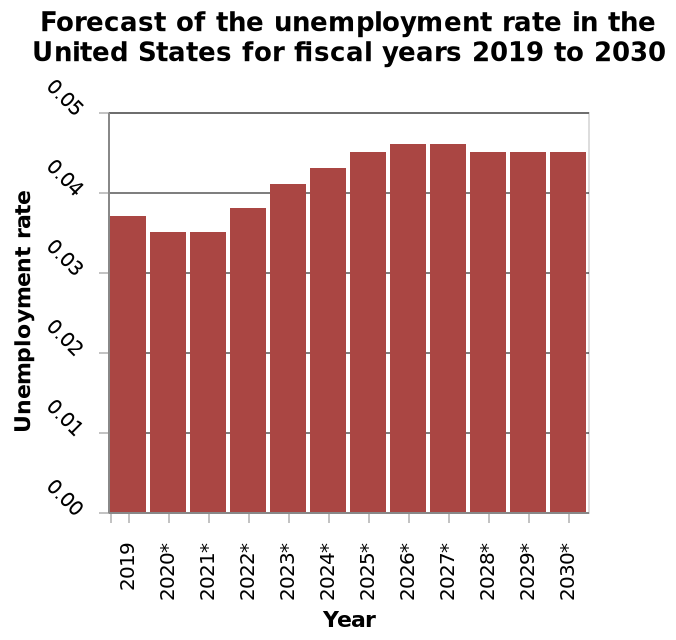<image>
Describe the following image in detail Here a is a bar graph called Forecast of the unemployment rate in the United States for fiscal years 2019 to 2030. The y-axis plots Unemployment rate with linear scale from 0.00 to 0.05 while the x-axis measures Year as categorical scale from 2019 to . What is the title of the graph?  The title of the graph is "Forecast of the unemployment rate in the United States for fiscal years 2019 to 2030." What does the y-axis represent?  The y-axis represents the unemployment rate in the United States. Is there a pie chart called Forecast of the unemployment rate in the United States for fiscal years 2019 to 2030? No.Here a is a bar graph called Forecast of the unemployment rate in the United States for fiscal years 2019 to 2030. The y-axis plots Unemployment rate with linear scale from 0.00 to 0.05 while the x-axis measures Year as categorical scale from 2019 to . 